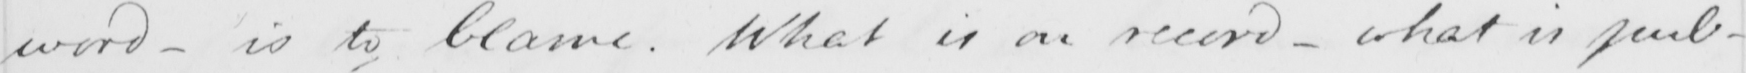What text is written in this handwritten line? word - is to blame . What is on record- what is pub- 